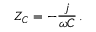Convert formula to latex. <formula><loc_0><loc_0><loc_500><loc_500>Z _ { C } = - { \frac { j } { \omega C } } \, .</formula> 